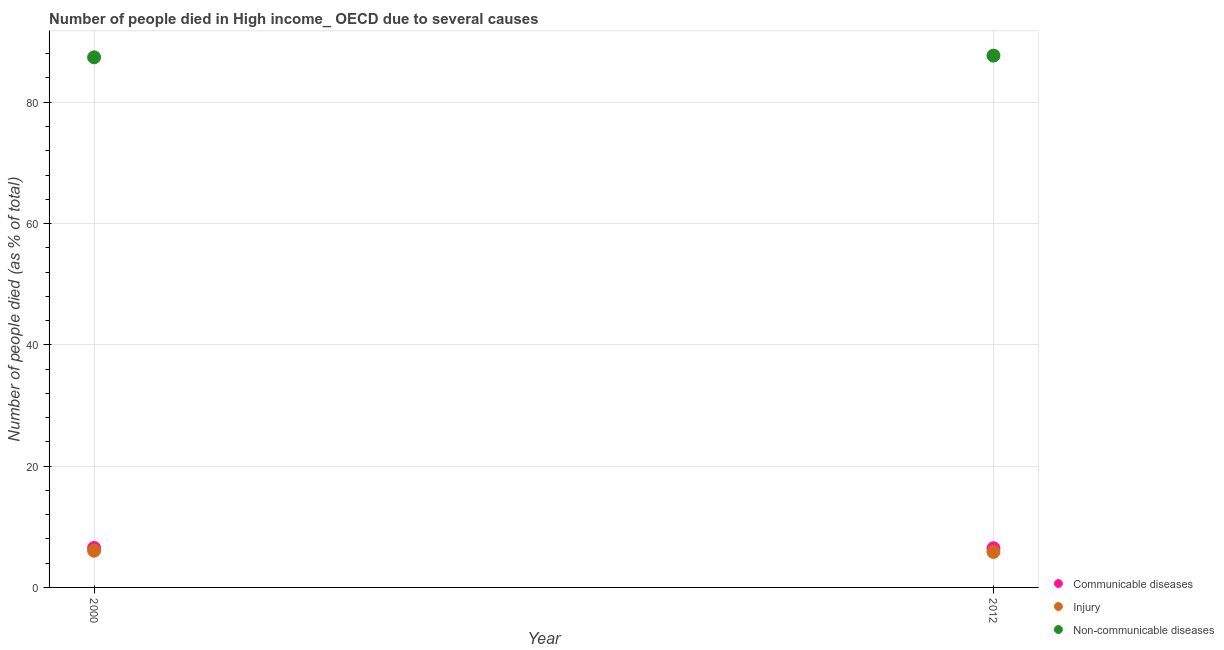How many different coloured dotlines are there?
Offer a very short reply. 3. What is the number of people who died of injury in 2000?
Offer a terse response. 6.05. Across all years, what is the maximum number of people who died of communicable diseases?
Provide a succinct answer. 6.51. Across all years, what is the minimum number of people who died of injury?
Make the answer very short. 5.85. In which year was the number of people who dies of non-communicable diseases maximum?
Provide a short and direct response. 2012. What is the total number of people who died of communicable diseases in the graph?
Your answer should be compact. 12.98. What is the difference between the number of people who died of injury in 2000 and that in 2012?
Provide a succinct answer. 0.2. What is the difference between the number of people who died of communicable diseases in 2012 and the number of people who dies of non-communicable diseases in 2000?
Keep it short and to the point. -80.94. What is the average number of people who died of communicable diseases per year?
Provide a short and direct response. 6.49. In the year 2012, what is the difference between the number of people who dies of non-communicable diseases and number of people who died of injury?
Your answer should be compact. 81.83. What is the ratio of the number of people who died of communicable diseases in 2000 to that in 2012?
Give a very brief answer. 1.01. Is the number of people who dies of non-communicable diseases in 2000 less than that in 2012?
Keep it short and to the point. Yes. In how many years, is the number of people who dies of non-communicable diseases greater than the average number of people who dies of non-communicable diseases taken over all years?
Keep it short and to the point. 1. How many dotlines are there?
Make the answer very short. 3. What is the difference between two consecutive major ticks on the Y-axis?
Offer a very short reply. 20. Are the values on the major ticks of Y-axis written in scientific E-notation?
Your response must be concise. No. Does the graph contain any zero values?
Offer a very short reply. No. Does the graph contain grids?
Provide a short and direct response. Yes. Where does the legend appear in the graph?
Your response must be concise. Bottom right. How are the legend labels stacked?
Your response must be concise. Vertical. What is the title of the graph?
Offer a terse response. Number of people died in High income_ OECD due to several causes. Does "Manufactures" appear as one of the legend labels in the graph?
Ensure brevity in your answer.  No. What is the label or title of the Y-axis?
Your response must be concise. Number of people died (as % of total). What is the Number of people died (as % of total) of Communicable diseases in 2000?
Ensure brevity in your answer.  6.51. What is the Number of people died (as % of total) of Injury in 2000?
Offer a terse response. 6.05. What is the Number of people died (as % of total) of Non-communicable diseases in 2000?
Ensure brevity in your answer.  87.4. What is the Number of people died (as % of total) of Communicable diseases in 2012?
Ensure brevity in your answer.  6.46. What is the Number of people died (as % of total) in Injury in 2012?
Offer a terse response. 5.85. What is the Number of people died (as % of total) in Non-communicable diseases in 2012?
Provide a short and direct response. 87.68. Across all years, what is the maximum Number of people died (as % of total) in Communicable diseases?
Provide a short and direct response. 6.51. Across all years, what is the maximum Number of people died (as % of total) in Injury?
Ensure brevity in your answer.  6.05. Across all years, what is the maximum Number of people died (as % of total) of Non-communicable diseases?
Ensure brevity in your answer.  87.68. Across all years, what is the minimum Number of people died (as % of total) in Communicable diseases?
Ensure brevity in your answer.  6.46. Across all years, what is the minimum Number of people died (as % of total) in Injury?
Your answer should be compact. 5.85. Across all years, what is the minimum Number of people died (as % of total) in Non-communicable diseases?
Provide a short and direct response. 87.4. What is the total Number of people died (as % of total) of Communicable diseases in the graph?
Your response must be concise. 12.98. What is the total Number of people died (as % of total) of Injury in the graph?
Provide a short and direct response. 11.91. What is the total Number of people died (as % of total) in Non-communicable diseases in the graph?
Give a very brief answer. 175.08. What is the difference between the Number of people died (as % of total) in Communicable diseases in 2000 and that in 2012?
Make the answer very short. 0.05. What is the difference between the Number of people died (as % of total) of Injury in 2000 and that in 2012?
Make the answer very short. 0.2. What is the difference between the Number of people died (as % of total) in Non-communicable diseases in 2000 and that in 2012?
Your answer should be very brief. -0.28. What is the difference between the Number of people died (as % of total) of Communicable diseases in 2000 and the Number of people died (as % of total) of Injury in 2012?
Your answer should be very brief. 0.66. What is the difference between the Number of people died (as % of total) in Communicable diseases in 2000 and the Number of people died (as % of total) in Non-communicable diseases in 2012?
Give a very brief answer. -81.17. What is the difference between the Number of people died (as % of total) in Injury in 2000 and the Number of people died (as % of total) in Non-communicable diseases in 2012?
Offer a very short reply. -81.63. What is the average Number of people died (as % of total) of Communicable diseases per year?
Provide a succinct answer. 6.49. What is the average Number of people died (as % of total) of Injury per year?
Provide a succinct answer. 5.95. What is the average Number of people died (as % of total) in Non-communicable diseases per year?
Offer a very short reply. 87.54. In the year 2000, what is the difference between the Number of people died (as % of total) of Communicable diseases and Number of people died (as % of total) of Injury?
Your response must be concise. 0.46. In the year 2000, what is the difference between the Number of people died (as % of total) in Communicable diseases and Number of people died (as % of total) in Non-communicable diseases?
Keep it short and to the point. -80.89. In the year 2000, what is the difference between the Number of people died (as % of total) of Injury and Number of people died (as % of total) of Non-communicable diseases?
Provide a succinct answer. -81.35. In the year 2012, what is the difference between the Number of people died (as % of total) in Communicable diseases and Number of people died (as % of total) in Injury?
Offer a very short reply. 0.61. In the year 2012, what is the difference between the Number of people died (as % of total) in Communicable diseases and Number of people died (as % of total) in Non-communicable diseases?
Your answer should be compact. -81.22. In the year 2012, what is the difference between the Number of people died (as % of total) in Injury and Number of people died (as % of total) in Non-communicable diseases?
Your answer should be compact. -81.83. What is the ratio of the Number of people died (as % of total) in Communicable diseases in 2000 to that in 2012?
Give a very brief answer. 1.01. What is the ratio of the Number of people died (as % of total) in Injury in 2000 to that in 2012?
Your answer should be compact. 1.03. What is the difference between the highest and the second highest Number of people died (as % of total) in Communicable diseases?
Provide a succinct answer. 0.05. What is the difference between the highest and the second highest Number of people died (as % of total) in Injury?
Give a very brief answer. 0.2. What is the difference between the highest and the second highest Number of people died (as % of total) of Non-communicable diseases?
Make the answer very short. 0.28. What is the difference between the highest and the lowest Number of people died (as % of total) in Communicable diseases?
Ensure brevity in your answer.  0.05. What is the difference between the highest and the lowest Number of people died (as % of total) of Injury?
Provide a succinct answer. 0.2. What is the difference between the highest and the lowest Number of people died (as % of total) of Non-communicable diseases?
Offer a terse response. 0.28. 